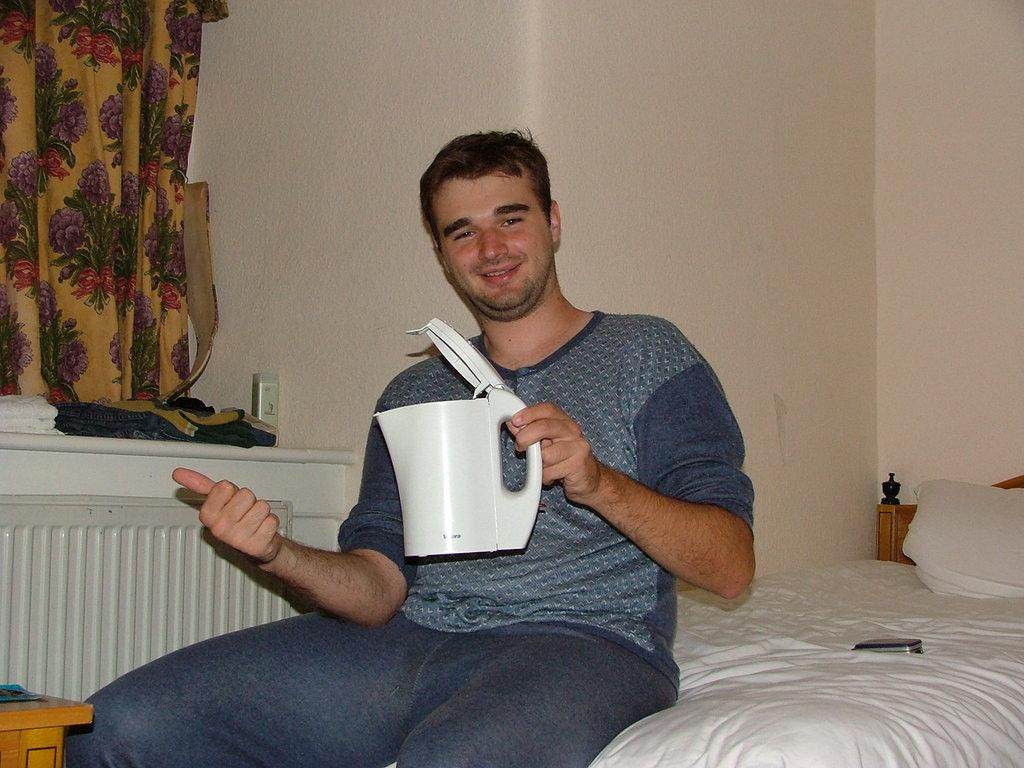What is the person in the image doing? There is a person sitting on a bed in the image. What is the person holding in his hand? The person is holding a flask in his hand. What other furniture can be seen in the image? There is a table in the image. What is on the table? There are clothes on the table. What is on the left side of the image? There is a curtain on the left side of the image. How many sisters does the person in the image have? There is no information about the person's sisters in the image, so it cannot be determined. 